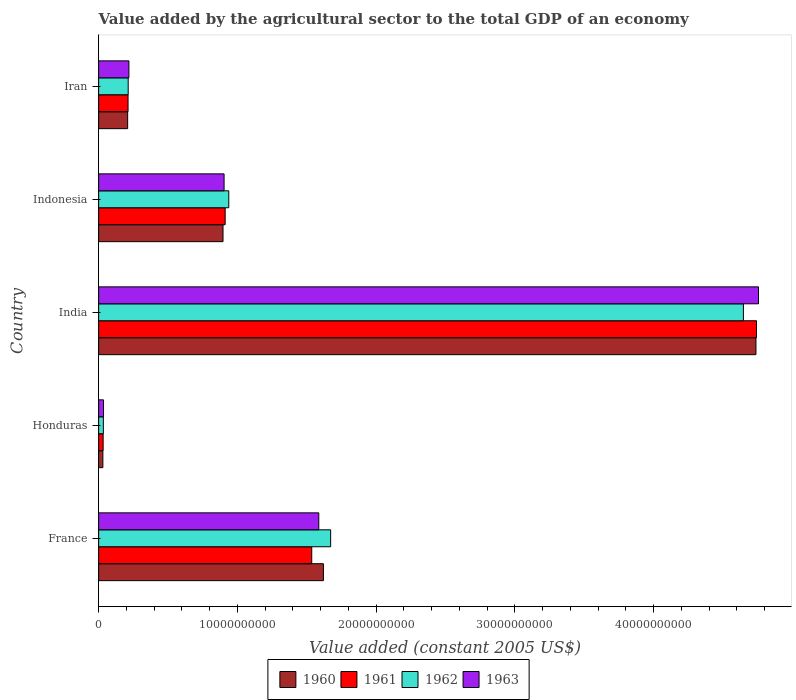How many different coloured bars are there?
Provide a succinct answer. 4. How many groups of bars are there?
Ensure brevity in your answer.  5. Are the number of bars on each tick of the Y-axis equal?
Your answer should be compact. Yes. How many bars are there on the 1st tick from the top?
Provide a succinct answer. 4. What is the label of the 4th group of bars from the top?
Give a very brief answer. Honduras. What is the value added by the agricultural sector in 1962 in India?
Keep it short and to the point. 4.65e+1. Across all countries, what is the maximum value added by the agricultural sector in 1960?
Give a very brief answer. 4.74e+1. Across all countries, what is the minimum value added by the agricultural sector in 1960?
Provide a short and direct response. 3.05e+08. In which country was the value added by the agricultural sector in 1962 maximum?
Provide a short and direct response. India. In which country was the value added by the agricultural sector in 1962 minimum?
Give a very brief answer. Honduras. What is the total value added by the agricultural sector in 1960 in the graph?
Your answer should be compact. 7.49e+1. What is the difference between the value added by the agricultural sector in 1962 in Indonesia and that in Iran?
Provide a succinct answer. 7.25e+09. What is the difference between the value added by the agricultural sector in 1961 in France and the value added by the agricultural sector in 1963 in Indonesia?
Provide a short and direct response. 6.32e+09. What is the average value added by the agricultural sector in 1962 per country?
Offer a very short reply. 1.50e+1. What is the difference between the value added by the agricultural sector in 1960 and value added by the agricultural sector in 1963 in Indonesia?
Your answer should be compact. -7.71e+07. In how many countries, is the value added by the agricultural sector in 1963 greater than 14000000000 US$?
Provide a short and direct response. 2. What is the ratio of the value added by the agricultural sector in 1962 in Indonesia to that in Iran?
Ensure brevity in your answer.  4.4. Is the value added by the agricultural sector in 1961 in Indonesia less than that in Iran?
Offer a terse response. No. What is the difference between the highest and the second highest value added by the agricultural sector in 1960?
Offer a very short reply. 3.12e+1. What is the difference between the highest and the lowest value added by the agricultural sector in 1963?
Give a very brief answer. 4.72e+1. In how many countries, is the value added by the agricultural sector in 1961 greater than the average value added by the agricultural sector in 1961 taken over all countries?
Your answer should be compact. 2. Is it the case that in every country, the sum of the value added by the agricultural sector in 1960 and value added by the agricultural sector in 1963 is greater than the sum of value added by the agricultural sector in 1962 and value added by the agricultural sector in 1961?
Keep it short and to the point. No. What does the 3rd bar from the top in India represents?
Ensure brevity in your answer.  1961. What does the 4th bar from the bottom in Honduras represents?
Ensure brevity in your answer.  1963. Is it the case that in every country, the sum of the value added by the agricultural sector in 1962 and value added by the agricultural sector in 1963 is greater than the value added by the agricultural sector in 1961?
Make the answer very short. Yes. Are all the bars in the graph horizontal?
Offer a very short reply. Yes. What is the difference between two consecutive major ticks on the X-axis?
Offer a very short reply. 1.00e+1. Where does the legend appear in the graph?
Your response must be concise. Bottom center. How are the legend labels stacked?
Ensure brevity in your answer.  Horizontal. What is the title of the graph?
Ensure brevity in your answer.  Value added by the agricultural sector to the total GDP of an economy. Does "1978" appear as one of the legend labels in the graph?
Your answer should be very brief. No. What is the label or title of the X-axis?
Ensure brevity in your answer.  Value added (constant 2005 US$). What is the Value added (constant 2005 US$) of 1960 in France?
Provide a short and direct response. 1.62e+1. What is the Value added (constant 2005 US$) of 1961 in France?
Your answer should be compact. 1.54e+1. What is the Value added (constant 2005 US$) in 1962 in France?
Offer a terse response. 1.67e+1. What is the Value added (constant 2005 US$) of 1963 in France?
Provide a short and direct response. 1.59e+1. What is the Value added (constant 2005 US$) in 1960 in Honduras?
Make the answer very short. 3.05e+08. What is the Value added (constant 2005 US$) of 1961 in Honduras?
Give a very brief answer. 3.25e+08. What is the Value added (constant 2005 US$) in 1962 in Honduras?
Make the answer very short. 3.41e+08. What is the Value added (constant 2005 US$) of 1963 in Honduras?
Give a very brief answer. 3.53e+08. What is the Value added (constant 2005 US$) of 1960 in India?
Your answer should be very brief. 4.74e+1. What is the Value added (constant 2005 US$) of 1961 in India?
Offer a very short reply. 4.74e+1. What is the Value added (constant 2005 US$) in 1962 in India?
Your response must be concise. 4.65e+1. What is the Value added (constant 2005 US$) of 1963 in India?
Give a very brief answer. 4.76e+1. What is the Value added (constant 2005 US$) of 1960 in Indonesia?
Your answer should be very brief. 8.96e+09. What is the Value added (constant 2005 US$) of 1961 in Indonesia?
Your answer should be compact. 9.12e+09. What is the Value added (constant 2005 US$) in 1962 in Indonesia?
Your answer should be compact. 9.38e+09. What is the Value added (constant 2005 US$) of 1963 in Indonesia?
Provide a short and direct response. 9.04e+09. What is the Value added (constant 2005 US$) of 1960 in Iran?
Give a very brief answer. 2.09e+09. What is the Value added (constant 2005 US$) of 1961 in Iran?
Offer a terse response. 2.12e+09. What is the Value added (constant 2005 US$) in 1962 in Iran?
Your answer should be very brief. 2.13e+09. What is the Value added (constant 2005 US$) of 1963 in Iran?
Offer a terse response. 2.18e+09. Across all countries, what is the maximum Value added (constant 2005 US$) in 1960?
Give a very brief answer. 4.74e+1. Across all countries, what is the maximum Value added (constant 2005 US$) of 1961?
Give a very brief answer. 4.74e+1. Across all countries, what is the maximum Value added (constant 2005 US$) in 1962?
Your answer should be very brief. 4.65e+1. Across all countries, what is the maximum Value added (constant 2005 US$) of 1963?
Provide a succinct answer. 4.76e+1. Across all countries, what is the minimum Value added (constant 2005 US$) of 1960?
Keep it short and to the point. 3.05e+08. Across all countries, what is the minimum Value added (constant 2005 US$) of 1961?
Your answer should be very brief. 3.25e+08. Across all countries, what is the minimum Value added (constant 2005 US$) in 1962?
Your answer should be very brief. 3.41e+08. Across all countries, what is the minimum Value added (constant 2005 US$) of 1963?
Offer a terse response. 3.53e+08. What is the total Value added (constant 2005 US$) in 1960 in the graph?
Your response must be concise. 7.49e+1. What is the total Value added (constant 2005 US$) of 1961 in the graph?
Your answer should be very brief. 7.43e+1. What is the total Value added (constant 2005 US$) in 1962 in the graph?
Your answer should be compact. 7.50e+1. What is the total Value added (constant 2005 US$) of 1963 in the graph?
Your answer should be compact. 7.50e+1. What is the difference between the Value added (constant 2005 US$) in 1960 in France and that in Honduras?
Your answer should be very brief. 1.59e+1. What is the difference between the Value added (constant 2005 US$) of 1961 in France and that in Honduras?
Provide a short and direct response. 1.50e+1. What is the difference between the Value added (constant 2005 US$) in 1962 in France and that in Honduras?
Offer a very short reply. 1.64e+1. What is the difference between the Value added (constant 2005 US$) in 1963 in France and that in Honduras?
Your answer should be very brief. 1.55e+1. What is the difference between the Value added (constant 2005 US$) of 1960 in France and that in India?
Your answer should be very brief. -3.12e+1. What is the difference between the Value added (constant 2005 US$) of 1961 in France and that in India?
Make the answer very short. -3.21e+1. What is the difference between the Value added (constant 2005 US$) in 1962 in France and that in India?
Keep it short and to the point. -2.97e+1. What is the difference between the Value added (constant 2005 US$) of 1963 in France and that in India?
Make the answer very short. -3.17e+1. What is the difference between the Value added (constant 2005 US$) in 1960 in France and that in Indonesia?
Your answer should be compact. 7.24e+09. What is the difference between the Value added (constant 2005 US$) in 1961 in France and that in Indonesia?
Offer a very short reply. 6.24e+09. What is the difference between the Value added (constant 2005 US$) in 1962 in France and that in Indonesia?
Ensure brevity in your answer.  7.34e+09. What is the difference between the Value added (constant 2005 US$) in 1963 in France and that in Indonesia?
Your response must be concise. 6.82e+09. What is the difference between the Value added (constant 2005 US$) in 1960 in France and that in Iran?
Keep it short and to the point. 1.41e+1. What is the difference between the Value added (constant 2005 US$) in 1961 in France and that in Iran?
Give a very brief answer. 1.32e+1. What is the difference between the Value added (constant 2005 US$) in 1962 in France and that in Iran?
Your answer should be very brief. 1.46e+1. What is the difference between the Value added (constant 2005 US$) in 1963 in France and that in Iran?
Ensure brevity in your answer.  1.37e+1. What is the difference between the Value added (constant 2005 US$) in 1960 in Honduras and that in India?
Make the answer very short. -4.71e+1. What is the difference between the Value added (constant 2005 US$) in 1961 in Honduras and that in India?
Ensure brevity in your answer.  -4.71e+1. What is the difference between the Value added (constant 2005 US$) of 1962 in Honduras and that in India?
Ensure brevity in your answer.  -4.61e+1. What is the difference between the Value added (constant 2005 US$) in 1963 in Honduras and that in India?
Offer a very short reply. -4.72e+1. What is the difference between the Value added (constant 2005 US$) in 1960 in Honduras and that in Indonesia?
Give a very brief answer. -8.66e+09. What is the difference between the Value added (constant 2005 US$) of 1961 in Honduras and that in Indonesia?
Give a very brief answer. -8.79e+09. What is the difference between the Value added (constant 2005 US$) in 1962 in Honduras and that in Indonesia?
Make the answer very short. -9.04e+09. What is the difference between the Value added (constant 2005 US$) of 1963 in Honduras and that in Indonesia?
Offer a very short reply. -8.69e+09. What is the difference between the Value added (constant 2005 US$) of 1960 in Honduras and that in Iran?
Provide a short and direct response. -1.79e+09. What is the difference between the Value added (constant 2005 US$) of 1961 in Honduras and that in Iran?
Offer a very short reply. -1.79e+09. What is the difference between the Value added (constant 2005 US$) of 1962 in Honduras and that in Iran?
Provide a succinct answer. -1.79e+09. What is the difference between the Value added (constant 2005 US$) of 1963 in Honduras and that in Iran?
Ensure brevity in your answer.  -1.83e+09. What is the difference between the Value added (constant 2005 US$) in 1960 in India and that in Indonesia?
Your answer should be very brief. 3.84e+1. What is the difference between the Value added (constant 2005 US$) in 1961 in India and that in Indonesia?
Make the answer very short. 3.83e+1. What is the difference between the Value added (constant 2005 US$) of 1962 in India and that in Indonesia?
Offer a very short reply. 3.71e+1. What is the difference between the Value added (constant 2005 US$) of 1963 in India and that in Indonesia?
Provide a short and direct response. 3.85e+1. What is the difference between the Value added (constant 2005 US$) in 1960 in India and that in Iran?
Provide a succinct answer. 4.53e+1. What is the difference between the Value added (constant 2005 US$) of 1961 in India and that in Iran?
Your answer should be very brief. 4.53e+1. What is the difference between the Value added (constant 2005 US$) in 1962 in India and that in Iran?
Provide a succinct answer. 4.43e+1. What is the difference between the Value added (constant 2005 US$) of 1963 in India and that in Iran?
Offer a very short reply. 4.54e+1. What is the difference between the Value added (constant 2005 US$) in 1960 in Indonesia and that in Iran?
Give a very brief answer. 6.87e+09. What is the difference between the Value added (constant 2005 US$) of 1961 in Indonesia and that in Iran?
Provide a succinct answer. 7.00e+09. What is the difference between the Value added (constant 2005 US$) of 1962 in Indonesia and that in Iran?
Offer a very short reply. 7.25e+09. What is the difference between the Value added (constant 2005 US$) in 1963 in Indonesia and that in Iran?
Ensure brevity in your answer.  6.86e+09. What is the difference between the Value added (constant 2005 US$) in 1960 in France and the Value added (constant 2005 US$) in 1961 in Honduras?
Provide a succinct answer. 1.59e+1. What is the difference between the Value added (constant 2005 US$) in 1960 in France and the Value added (constant 2005 US$) in 1962 in Honduras?
Give a very brief answer. 1.59e+1. What is the difference between the Value added (constant 2005 US$) of 1960 in France and the Value added (constant 2005 US$) of 1963 in Honduras?
Offer a terse response. 1.58e+1. What is the difference between the Value added (constant 2005 US$) of 1961 in France and the Value added (constant 2005 US$) of 1962 in Honduras?
Your answer should be very brief. 1.50e+1. What is the difference between the Value added (constant 2005 US$) in 1961 in France and the Value added (constant 2005 US$) in 1963 in Honduras?
Your answer should be very brief. 1.50e+1. What is the difference between the Value added (constant 2005 US$) in 1962 in France and the Value added (constant 2005 US$) in 1963 in Honduras?
Make the answer very short. 1.64e+1. What is the difference between the Value added (constant 2005 US$) of 1960 in France and the Value added (constant 2005 US$) of 1961 in India?
Offer a very short reply. -3.12e+1. What is the difference between the Value added (constant 2005 US$) in 1960 in France and the Value added (constant 2005 US$) in 1962 in India?
Provide a succinct answer. -3.03e+1. What is the difference between the Value added (constant 2005 US$) of 1960 in France and the Value added (constant 2005 US$) of 1963 in India?
Ensure brevity in your answer.  -3.14e+1. What is the difference between the Value added (constant 2005 US$) in 1961 in France and the Value added (constant 2005 US$) in 1962 in India?
Give a very brief answer. -3.11e+1. What is the difference between the Value added (constant 2005 US$) in 1961 in France and the Value added (constant 2005 US$) in 1963 in India?
Your answer should be very brief. -3.22e+1. What is the difference between the Value added (constant 2005 US$) of 1962 in France and the Value added (constant 2005 US$) of 1963 in India?
Make the answer very short. -3.08e+1. What is the difference between the Value added (constant 2005 US$) of 1960 in France and the Value added (constant 2005 US$) of 1961 in Indonesia?
Keep it short and to the point. 7.08e+09. What is the difference between the Value added (constant 2005 US$) in 1960 in France and the Value added (constant 2005 US$) in 1962 in Indonesia?
Keep it short and to the point. 6.82e+09. What is the difference between the Value added (constant 2005 US$) of 1960 in France and the Value added (constant 2005 US$) of 1963 in Indonesia?
Give a very brief answer. 7.16e+09. What is the difference between the Value added (constant 2005 US$) of 1961 in France and the Value added (constant 2005 US$) of 1962 in Indonesia?
Offer a terse response. 5.98e+09. What is the difference between the Value added (constant 2005 US$) in 1961 in France and the Value added (constant 2005 US$) in 1963 in Indonesia?
Provide a succinct answer. 6.32e+09. What is the difference between the Value added (constant 2005 US$) in 1962 in France and the Value added (constant 2005 US$) in 1963 in Indonesia?
Offer a very short reply. 7.68e+09. What is the difference between the Value added (constant 2005 US$) in 1960 in France and the Value added (constant 2005 US$) in 1961 in Iran?
Provide a short and direct response. 1.41e+1. What is the difference between the Value added (constant 2005 US$) of 1960 in France and the Value added (constant 2005 US$) of 1962 in Iran?
Your answer should be compact. 1.41e+1. What is the difference between the Value added (constant 2005 US$) in 1960 in France and the Value added (constant 2005 US$) in 1963 in Iran?
Provide a succinct answer. 1.40e+1. What is the difference between the Value added (constant 2005 US$) of 1961 in France and the Value added (constant 2005 US$) of 1962 in Iran?
Provide a succinct answer. 1.32e+1. What is the difference between the Value added (constant 2005 US$) of 1961 in France and the Value added (constant 2005 US$) of 1963 in Iran?
Your answer should be very brief. 1.32e+1. What is the difference between the Value added (constant 2005 US$) of 1962 in France and the Value added (constant 2005 US$) of 1963 in Iran?
Provide a succinct answer. 1.45e+1. What is the difference between the Value added (constant 2005 US$) of 1960 in Honduras and the Value added (constant 2005 US$) of 1961 in India?
Make the answer very short. -4.71e+1. What is the difference between the Value added (constant 2005 US$) in 1960 in Honduras and the Value added (constant 2005 US$) in 1962 in India?
Keep it short and to the point. -4.62e+1. What is the difference between the Value added (constant 2005 US$) in 1960 in Honduras and the Value added (constant 2005 US$) in 1963 in India?
Your response must be concise. -4.72e+1. What is the difference between the Value added (constant 2005 US$) in 1961 in Honduras and the Value added (constant 2005 US$) in 1962 in India?
Offer a terse response. -4.61e+1. What is the difference between the Value added (constant 2005 US$) of 1961 in Honduras and the Value added (constant 2005 US$) of 1963 in India?
Your answer should be very brief. -4.72e+1. What is the difference between the Value added (constant 2005 US$) of 1962 in Honduras and the Value added (constant 2005 US$) of 1963 in India?
Make the answer very short. -4.72e+1. What is the difference between the Value added (constant 2005 US$) of 1960 in Honduras and the Value added (constant 2005 US$) of 1961 in Indonesia?
Offer a very short reply. -8.81e+09. What is the difference between the Value added (constant 2005 US$) of 1960 in Honduras and the Value added (constant 2005 US$) of 1962 in Indonesia?
Ensure brevity in your answer.  -9.07e+09. What is the difference between the Value added (constant 2005 US$) in 1960 in Honduras and the Value added (constant 2005 US$) in 1963 in Indonesia?
Your answer should be very brief. -8.73e+09. What is the difference between the Value added (constant 2005 US$) in 1961 in Honduras and the Value added (constant 2005 US$) in 1962 in Indonesia?
Ensure brevity in your answer.  -9.05e+09. What is the difference between the Value added (constant 2005 US$) of 1961 in Honduras and the Value added (constant 2005 US$) of 1963 in Indonesia?
Your answer should be very brief. -8.72e+09. What is the difference between the Value added (constant 2005 US$) in 1962 in Honduras and the Value added (constant 2005 US$) in 1963 in Indonesia?
Make the answer very short. -8.70e+09. What is the difference between the Value added (constant 2005 US$) in 1960 in Honduras and the Value added (constant 2005 US$) in 1961 in Iran?
Provide a short and direct response. -1.81e+09. What is the difference between the Value added (constant 2005 US$) in 1960 in Honduras and the Value added (constant 2005 US$) in 1962 in Iran?
Ensure brevity in your answer.  -1.82e+09. What is the difference between the Value added (constant 2005 US$) in 1960 in Honduras and the Value added (constant 2005 US$) in 1963 in Iran?
Your response must be concise. -1.88e+09. What is the difference between the Value added (constant 2005 US$) in 1961 in Honduras and the Value added (constant 2005 US$) in 1962 in Iran?
Keep it short and to the point. -1.80e+09. What is the difference between the Value added (constant 2005 US$) in 1961 in Honduras and the Value added (constant 2005 US$) in 1963 in Iran?
Ensure brevity in your answer.  -1.86e+09. What is the difference between the Value added (constant 2005 US$) of 1962 in Honduras and the Value added (constant 2005 US$) of 1963 in Iran?
Your answer should be very brief. -1.84e+09. What is the difference between the Value added (constant 2005 US$) of 1960 in India and the Value added (constant 2005 US$) of 1961 in Indonesia?
Ensure brevity in your answer.  3.83e+1. What is the difference between the Value added (constant 2005 US$) in 1960 in India and the Value added (constant 2005 US$) in 1962 in Indonesia?
Your answer should be very brief. 3.80e+1. What is the difference between the Value added (constant 2005 US$) in 1960 in India and the Value added (constant 2005 US$) in 1963 in Indonesia?
Offer a very short reply. 3.83e+1. What is the difference between the Value added (constant 2005 US$) in 1961 in India and the Value added (constant 2005 US$) in 1962 in Indonesia?
Your answer should be very brief. 3.80e+1. What is the difference between the Value added (constant 2005 US$) of 1961 in India and the Value added (constant 2005 US$) of 1963 in Indonesia?
Give a very brief answer. 3.84e+1. What is the difference between the Value added (constant 2005 US$) in 1962 in India and the Value added (constant 2005 US$) in 1963 in Indonesia?
Your answer should be very brief. 3.74e+1. What is the difference between the Value added (constant 2005 US$) of 1960 in India and the Value added (constant 2005 US$) of 1961 in Iran?
Offer a very short reply. 4.52e+1. What is the difference between the Value added (constant 2005 US$) of 1960 in India and the Value added (constant 2005 US$) of 1962 in Iran?
Make the answer very short. 4.52e+1. What is the difference between the Value added (constant 2005 US$) of 1960 in India and the Value added (constant 2005 US$) of 1963 in Iran?
Your answer should be very brief. 4.52e+1. What is the difference between the Value added (constant 2005 US$) in 1961 in India and the Value added (constant 2005 US$) in 1962 in Iran?
Your response must be concise. 4.53e+1. What is the difference between the Value added (constant 2005 US$) of 1961 in India and the Value added (constant 2005 US$) of 1963 in Iran?
Offer a terse response. 4.52e+1. What is the difference between the Value added (constant 2005 US$) of 1962 in India and the Value added (constant 2005 US$) of 1963 in Iran?
Make the answer very short. 4.43e+1. What is the difference between the Value added (constant 2005 US$) of 1960 in Indonesia and the Value added (constant 2005 US$) of 1961 in Iran?
Keep it short and to the point. 6.84e+09. What is the difference between the Value added (constant 2005 US$) in 1960 in Indonesia and the Value added (constant 2005 US$) in 1962 in Iran?
Provide a short and direct response. 6.83e+09. What is the difference between the Value added (constant 2005 US$) in 1960 in Indonesia and the Value added (constant 2005 US$) in 1963 in Iran?
Make the answer very short. 6.78e+09. What is the difference between the Value added (constant 2005 US$) in 1961 in Indonesia and the Value added (constant 2005 US$) in 1962 in Iran?
Offer a very short reply. 6.99e+09. What is the difference between the Value added (constant 2005 US$) of 1961 in Indonesia and the Value added (constant 2005 US$) of 1963 in Iran?
Your answer should be compact. 6.94e+09. What is the difference between the Value added (constant 2005 US$) in 1962 in Indonesia and the Value added (constant 2005 US$) in 1963 in Iran?
Offer a terse response. 7.20e+09. What is the average Value added (constant 2005 US$) in 1960 per country?
Keep it short and to the point. 1.50e+1. What is the average Value added (constant 2005 US$) in 1961 per country?
Make the answer very short. 1.49e+1. What is the average Value added (constant 2005 US$) in 1962 per country?
Provide a succinct answer. 1.50e+1. What is the average Value added (constant 2005 US$) in 1963 per country?
Provide a succinct answer. 1.50e+1. What is the difference between the Value added (constant 2005 US$) in 1960 and Value added (constant 2005 US$) in 1961 in France?
Give a very brief answer. 8.42e+08. What is the difference between the Value added (constant 2005 US$) in 1960 and Value added (constant 2005 US$) in 1962 in France?
Provide a succinct answer. -5.20e+08. What is the difference between the Value added (constant 2005 US$) of 1960 and Value added (constant 2005 US$) of 1963 in France?
Your answer should be compact. 3.35e+08. What is the difference between the Value added (constant 2005 US$) of 1961 and Value added (constant 2005 US$) of 1962 in France?
Provide a short and direct response. -1.36e+09. What is the difference between the Value added (constant 2005 US$) in 1961 and Value added (constant 2005 US$) in 1963 in France?
Provide a short and direct response. -5.07e+08. What is the difference between the Value added (constant 2005 US$) of 1962 and Value added (constant 2005 US$) of 1963 in France?
Provide a succinct answer. 8.56e+08. What is the difference between the Value added (constant 2005 US$) of 1960 and Value added (constant 2005 US$) of 1961 in Honduras?
Provide a short and direct response. -1.99e+07. What is the difference between the Value added (constant 2005 US$) of 1960 and Value added (constant 2005 US$) of 1962 in Honduras?
Offer a terse response. -3.54e+07. What is the difference between the Value added (constant 2005 US$) in 1960 and Value added (constant 2005 US$) in 1963 in Honduras?
Provide a short and direct response. -4.78e+07. What is the difference between the Value added (constant 2005 US$) of 1961 and Value added (constant 2005 US$) of 1962 in Honduras?
Offer a terse response. -1.55e+07. What is the difference between the Value added (constant 2005 US$) in 1961 and Value added (constant 2005 US$) in 1963 in Honduras?
Make the answer very short. -2.79e+07. What is the difference between the Value added (constant 2005 US$) in 1962 and Value added (constant 2005 US$) in 1963 in Honduras?
Your response must be concise. -1.24e+07. What is the difference between the Value added (constant 2005 US$) in 1960 and Value added (constant 2005 US$) in 1961 in India?
Provide a succinct answer. -3.99e+07. What is the difference between the Value added (constant 2005 US$) of 1960 and Value added (constant 2005 US$) of 1962 in India?
Keep it short and to the point. 9.03e+08. What is the difference between the Value added (constant 2005 US$) of 1960 and Value added (constant 2005 US$) of 1963 in India?
Your answer should be compact. -1.84e+08. What is the difference between the Value added (constant 2005 US$) of 1961 and Value added (constant 2005 US$) of 1962 in India?
Offer a very short reply. 9.43e+08. What is the difference between the Value added (constant 2005 US$) of 1961 and Value added (constant 2005 US$) of 1963 in India?
Your response must be concise. -1.44e+08. What is the difference between the Value added (constant 2005 US$) in 1962 and Value added (constant 2005 US$) in 1963 in India?
Keep it short and to the point. -1.09e+09. What is the difference between the Value added (constant 2005 US$) in 1960 and Value added (constant 2005 US$) in 1961 in Indonesia?
Offer a terse response. -1.54e+08. What is the difference between the Value added (constant 2005 US$) in 1960 and Value added (constant 2005 US$) in 1962 in Indonesia?
Keep it short and to the point. -4.16e+08. What is the difference between the Value added (constant 2005 US$) of 1960 and Value added (constant 2005 US$) of 1963 in Indonesia?
Your response must be concise. -7.71e+07. What is the difference between the Value added (constant 2005 US$) in 1961 and Value added (constant 2005 US$) in 1962 in Indonesia?
Your answer should be compact. -2.62e+08. What is the difference between the Value added (constant 2005 US$) in 1961 and Value added (constant 2005 US$) in 1963 in Indonesia?
Make the answer very short. 7.71e+07. What is the difference between the Value added (constant 2005 US$) of 1962 and Value added (constant 2005 US$) of 1963 in Indonesia?
Make the answer very short. 3.39e+08. What is the difference between the Value added (constant 2005 US$) in 1960 and Value added (constant 2005 US$) in 1961 in Iran?
Offer a terse response. -2.84e+07. What is the difference between the Value added (constant 2005 US$) in 1960 and Value added (constant 2005 US$) in 1962 in Iran?
Offer a terse response. -3.89e+07. What is the difference between the Value added (constant 2005 US$) of 1960 and Value added (constant 2005 US$) of 1963 in Iran?
Offer a terse response. -9.02e+07. What is the difference between the Value added (constant 2005 US$) in 1961 and Value added (constant 2005 US$) in 1962 in Iran?
Provide a succinct answer. -1.05e+07. What is the difference between the Value added (constant 2005 US$) of 1961 and Value added (constant 2005 US$) of 1963 in Iran?
Offer a very short reply. -6.18e+07. What is the difference between the Value added (constant 2005 US$) of 1962 and Value added (constant 2005 US$) of 1963 in Iran?
Ensure brevity in your answer.  -5.13e+07. What is the ratio of the Value added (constant 2005 US$) in 1960 in France to that in Honduras?
Offer a terse response. 53.05. What is the ratio of the Value added (constant 2005 US$) of 1961 in France to that in Honduras?
Your answer should be very brief. 47.21. What is the ratio of the Value added (constant 2005 US$) of 1962 in France to that in Honduras?
Your answer should be very brief. 49.07. What is the ratio of the Value added (constant 2005 US$) of 1963 in France to that in Honduras?
Keep it short and to the point. 44.92. What is the ratio of the Value added (constant 2005 US$) in 1960 in France to that in India?
Ensure brevity in your answer.  0.34. What is the ratio of the Value added (constant 2005 US$) in 1961 in France to that in India?
Your answer should be very brief. 0.32. What is the ratio of the Value added (constant 2005 US$) of 1962 in France to that in India?
Provide a succinct answer. 0.36. What is the ratio of the Value added (constant 2005 US$) of 1963 in France to that in India?
Provide a succinct answer. 0.33. What is the ratio of the Value added (constant 2005 US$) of 1960 in France to that in Indonesia?
Keep it short and to the point. 1.81. What is the ratio of the Value added (constant 2005 US$) of 1961 in France to that in Indonesia?
Provide a short and direct response. 1.68. What is the ratio of the Value added (constant 2005 US$) of 1962 in France to that in Indonesia?
Keep it short and to the point. 1.78. What is the ratio of the Value added (constant 2005 US$) in 1963 in France to that in Indonesia?
Offer a terse response. 1.75. What is the ratio of the Value added (constant 2005 US$) of 1960 in France to that in Iran?
Offer a terse response. 7.75. What is the ratio of the Value added (constant 2005 US$) in 1961 in France to that in Iran?
Keep it short and to the point. 7.24. What is the ratio of the Value added (constant 2005 US$) in 1962 in France to that in Iran?
Give a very brief answer. 7.85. What is the ratio of the Value added (constant 2005 US$) in 1963 in France to that in Iran?
Provide a short and direct response. 7.27. What is the ratio of the Value added (constant 2005 US$) of 1960 in Honduras to that in India?
Your response must be concise. 0.01. What is the ratio of the Value added (constant 2005 US$) in 1961 in Honduras to that in India?
Offer a very short reply. 0.01. What is the ratio of the Value added (constant 2005 US$) of 1962 in Honduras to that in India?
Your answer should be very brief. 0.01. What is the ratio of the Value added (constant 2005 US$) in 1963 in Honduras to that in India?
Make the answer very short. 0.01. What is the ratio of the Value added (constant 2005 US$) of 1960 in Honduras to that in Indonesia?
Keep it short and to the point. 0.03. What is the ratio of the Value added (constant 2005 US$) in 1961 in Honduras to that in Indonesia?
Provide a short and direct response. 0.04. What is the ratio of the Value added (constant 2005 US$) in 1962 in Honduras to that in Indonesia?
Ensure brevity in your answer.  0.04. What is the ratio of the Value added (constant 2005 US$) of 1963 in Honduras to that in Indonesia?
Offer a very short reply. 0.04. What is the ratio of the Value added (constant 2005 US$) of 1960 in Honduras to that in Iran?
Make the answer very short. 0.15. What is the ratio of the Value added (constant 2005 US$) of 1961 in Honduras to that in Iran?
Your answer should be compact. 0.15. What is the ratio of the Value added (constant 2005 US$) of 1962 in Honduras to that in Iran?
Provide a succinct answer. 0.16. What is the ratio of the Value added (constant 2005 US$) in 1963 in Honduras to that in Iran?
Offer a very short reply. 0.16. What is the ratio of the Value added (constant 2005 US$) in 1960 in India to that in Indonesia?
Ensure brevity in your answer.  5.28. What is the ratio of the Value added (constant 2005 US$) in 1961 in India to that in Indonesia?
Your response must be concise. 5.2. What is the ratio of the Value added (constant 2005 US$) of 1962 in India to that in Indonesia?
Provide a short and direct response. 4.95. What is the ratio of the Value added (constant 2005 US$) of 1963 in India to that in Indonesia?
Ensure brevity in your answer.  5.26. What is the ratio of the Value added (constant 2005 US$) in 1960 in India to that in Iran?
Ensure brevity in your answer.  22.65. What is the ratio of the Value added (constant 2005 US$) in 1961 in India to that in Iran?
Make the answer very short. 22.37. What is the ratio of the Value added (constant 2005 US$) in 1962 in India to that in Iran?
Offer a terse response. 21.81. What is the ratio of the Value added (constant 2005 US$) of 1963 in India to that in Iran?
Your answer should be compact. 21.8. What is the ratio of the Value added (constant 2005 US$) of 1960 in Indonesia to that in Iran?
Provide a short and direct response. 4.29. What is the ratio of the Value added (constant 2005 US$) in 1961 in Indonesia to that in Iran?
Your answer should be very brief. 4.3. What is the ratio of the Value added (constant 2005 US$) of 1962 in Indonesia to that in Iran?
Provide a short and direct response. 4.4. What is the ratio of the Value added (constant 2005 US$) of 1963 in Indonesia to that in Iran?
Ensure brevity in your answer.  4.14. What is the difference between the highest and the second highest Value added (constant 2005 US$) in 1960?
Your answer should be very brief. 3.12e+1. What is the difference between the highest and the second highest Value added (constant 2005 US$) of 1961?
Offer a very short reply. 3.21e+1. What is the difference between the highest and the second highest Value added (constant 2005 US$) in 1962?
Provide a succinct answer. 2.97e+1. What is the difference between the highest and the second highest Value added (constant 2005 US$) in 1963?
Offer a very short reply. 3.17e+1. What is the difference between the highest and the lowest Value added (constant 2005 US$) of 1960?
Your response must be concise. 4.71e+1. What is the difference between the highest and the lowest Value added (constant 2005 US$) of 1961?
Offer a very short reply. 4.71e+1. What is the difference between the highest and the lowest Value added (constant 2005 US$) of 1962?
Your answer should be very brief. 4.61e+1. What is the difference between the highest and the lowest Value added (constant 2005 US$) in 1963?
Offer a very short reply. 4.72e+1. 